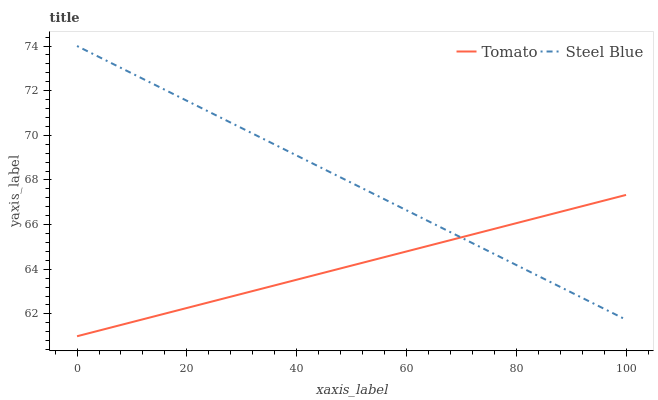Does Tomato have the minimum area under the curve?
Answer yes or no. Yes. Does Steel Blue have the maximum area under the curve?
Answer yes or no. Yes. Does Steel Blue have the minimum area under the curve?
Answer yes or no. No. Is Steel Blue the smoothest?
Answer yes or no. Yes. Is Tomato the roughest?
Answer yes or no. Yes. Is Steel Blue the roughest?
Answer yes or no. No. Does Steel Blue have the lowest value?
Answer yes or no. No. 